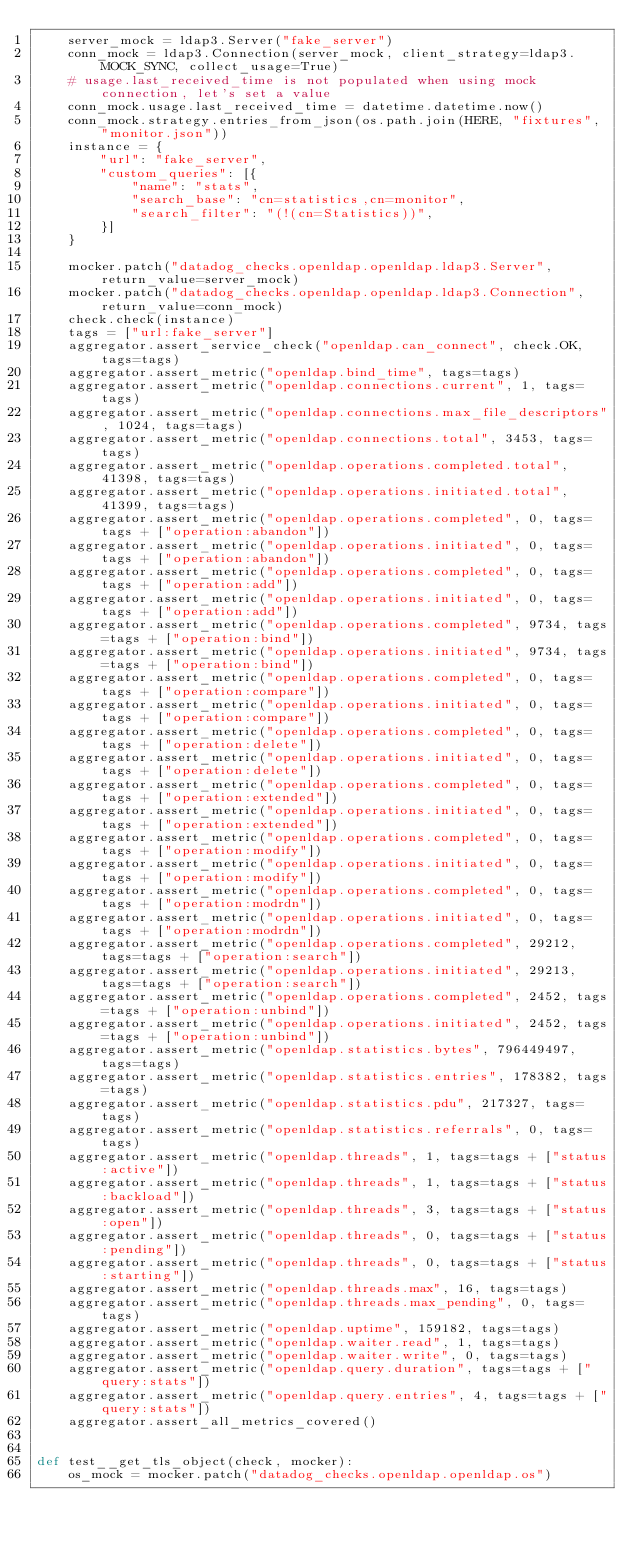<code> <loc_0><loc_0><loc_500><loc_500><_Python_>    server_mock = ldap3.Server("fake_server")
    conn_mock = ldap3.Connection(server_mock, client_strategy=ldap3.MOCK_SYNC, collect_usage=True)
    # usage.last_received_time is not populated when using mock connection, let's set a value
    conn_mock.usage.last_received_time = datetime.datetime.now()
    conn_mock.strategy.entries_from_json(os.path.join(HERE, "fixtures", "monitor.json"))
    instance = {
        "url": "fake_server",
        "custom_queries": [{
            "name": "stats",
            "search_base": "cn=statistics,cn=monitor",
            "search_filter": "(!(cn=Statistics))",
        }]
    }

    mocker.patch("datadog_checks.openldap.openldap.ldap3.Server", return_value=server_mock)
    mocker.patch("datadog_checks.openldap.openldap.ldap3.Connection", return_value=conn_mock)
    check.check(instance)
    tags = ["url:fake_server"]
    aggregator.assert_service_check("openldap.can_connect", check.OK, tags=tags)
    aggregator.assert_metric("openldap.bind_time", tags=tags)
    aggregator.assert_metric("openldap.connections.current", 1, tags=tags)
    aggregator.assert_metric("openldap.connections.max_file_descriptors", 1024, tags=tags)
    aggregator.assert_metric("openldap.connections.total", 3453, tags=tags)
    aggregator.assert_metric("openldap.operations.completed.total", 41398, tags=tags)
    aggregator.assert_metric("openldap.operations.initiated.total", 41399, tags=tags)
    aggregator.assert_metric("openldap.operations.completed", 0, tags=tags + ["operation:abandon"])
    aggregator.assert_metric("openldap.operations.initiated", 0, tags=tags + ["operation:abandon"])
    aggregator.assert_metric("openldap.operations.completed", 0, tags=tags + ["operation:add"])
    aggregator.assert_metric("openldap.operations.initiated", 0, tags=tags + ["operation:add"])
    aggregator.assert_metric("openldap.operations.completed", 9734, tags=tags + ["operation:bind"])
    aggregator.assert_metric("openldap.operations.initiated", 9734, tags=tags + ["operation:bind"])
    aggregator.assert_metric("openldap.operations.completed", 0, tags=tags + ["operation:compare"])
    aggregator.assert_metric("openldap.operations.initiated", 0, tags=tags + ["operation:compare"])
    aggregator.assert_metric("openldap.operations.completed", 0, tags=tags + ["operation:delete"])
    aggregator.assert_metric("openldap.operations.initiated", 0, tags=tags + ["operation:delete"])
    aggregator.assert_metric("openldap.operations.completed", 0, tags=tags + ["operation:extended"])
    aggregator.assert_metric("openldap.operations.initiated", 0, tags=tags + ["operation:extended"])
    aggregator.assert_metric("openldap.operations.completed", 0, tags=tags + ["operation:modify"])
    aggregator.assert_metric("openldap.operations.initiated", 0, tags=tags + ["operation:modify"])
    aggregator.assert_metric("openldap.operations.completed", 0, tags=tags + ["operation:modrdn"])
    aggregator.assert_metric("openldap.operations.initiated", 0, tags=tags + ["operation:modrdn"])
    aggregator.assert_metric("openldap.operations.completed", 29212, tags=tags + ["operation:search"])
    aggregator.assert_metric("openldap.operations.initiated", 29213, tags=tags + ["operation:search"])
    aggregator.assert_metric("openldap.operations.completed", 2452, tags=tags + ["operation:unbind"])
    aggregator.assert_metric("openldap.operations.initiated", 2452, tags=tags + ["operation:unbind"])
    aggregator.assert_metric("openldap.statistics.bytes", 796449497, tags=tags)
    aggregator.assert_metric("openldap.statistics.entries", 178382, tags=tags)
    aggregator.assert_metric("openldap.statistics.pdu", 217327, tags=tags)
    aggregator.assert_metric("openldap.statistics.referrals", 0, tags=tags)
    aggregator.assert_metric("openldap.threads", 1, tags=tags + ["status:active"])
    aggregator.assert_metric("openldap.threads", 1, tags=tags + ["status:backload"])
    aggregator.assert_metric("openldap.threads", 3, tags=tags + ["status:open"])
    aggregator.assert_metric("openldap.threads", 0, tags=tags + ["status:pending"])
    aggregator.assert_metric("openldap.threads", 0, tags=tags + ["status:starting"])
    aggregator.assert_metric("openldap.threads.max", 16, tags=tags)
    aggregator.assert_metric("openldap.threads.max_pending", 0, tags=tags)
    aggregator.assert_metric("openldap.uptime", 159182, tags=tags)
    aggregator.assert_metric("openldap.waiter.read", 1, tags=tags)
    aggregator.assert_metric("openldap.waiter.write", 0, tags=tags)
    aggregator.assert_metric("openldap.query.duration", tags=tags + ["query:stats"])
    aggregator.assert_metric("openldap.query.entries", 4, tags=tags + ["query:stats"])
    aggregator.assert_all_metrics_covered()


def test__get_tls_object(check, mocker):
    os_mock = mocker.patch("datadog_checks.openldap.openldap.os")</code> 